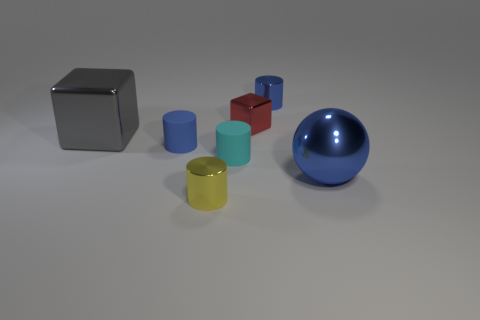Does the yellow metal cylinder have the same size as the cyan matte cylinder?
Offer a terse response. Yes. There is a blue object that is on the right side of the small blue rubber cylinder and in front of the gray metal cube; what size is it?
Give a very brief answer. Large. What is the shape of the small red thing that is the same material as the gray object?
Your answer should be very brief. Cube. Are there fewer gray metal blocks in front of the big metallic ball than tiny cyan things that are to the right of the small cyan cylinder?
Your response must be concise. No. What is the shape of the tiny metal thing that is the same color as the big ball?
Your answer should be very brief. Cylinder. How many other cylinders have the same size as the yellow cylinder?
Give a very brief answer. 3. What size is the blue ball that is made of the same material as the tiny yellow object?
Provide a short and direct response. Large. There is a metal thing that is the same color as the big ball; what is its size?
Keep it short and to the point. Small. The large metallic block is what color?
Your response must be concise. Gray. What is the size of the matte thing to the right of the tiny rubber cylinder to the left of the small object in front of the ball?
Ensure brevity in your answer.  Small. 